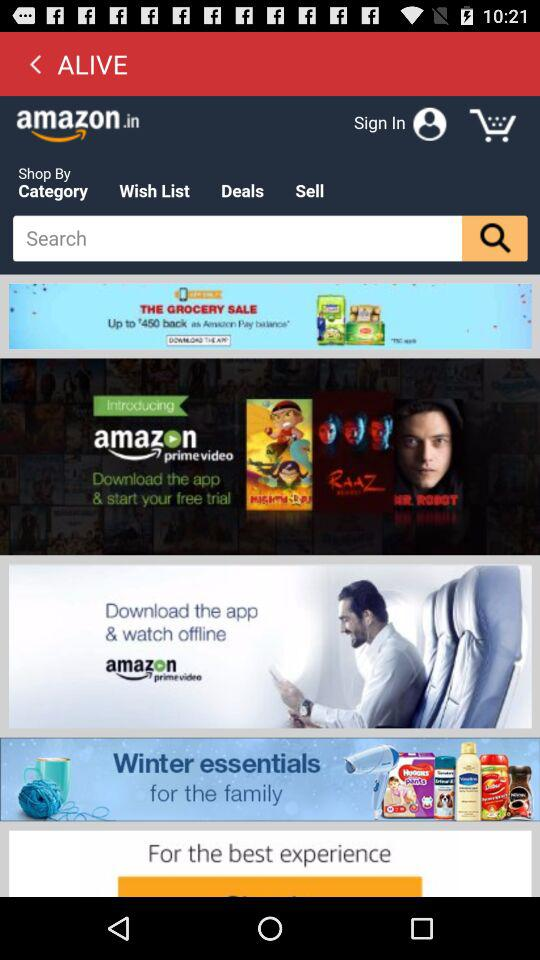What is the name of the application? The application name is "ALIVE". 